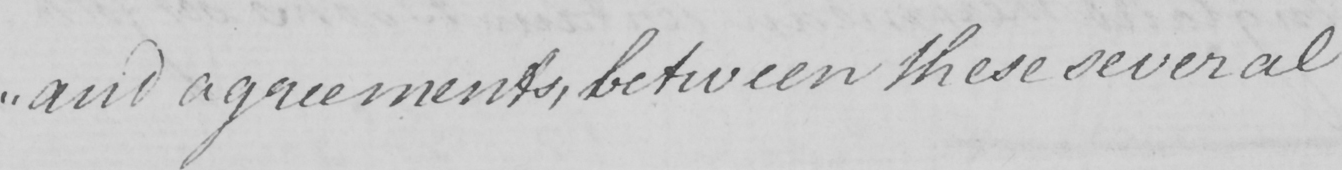Please transcribe the handwritten text in this image. " and agreements , between these several  _ 